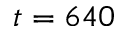<formula> <loc_0><loc_0><loc_500><loc_500>t = 6 4 0</formula> 